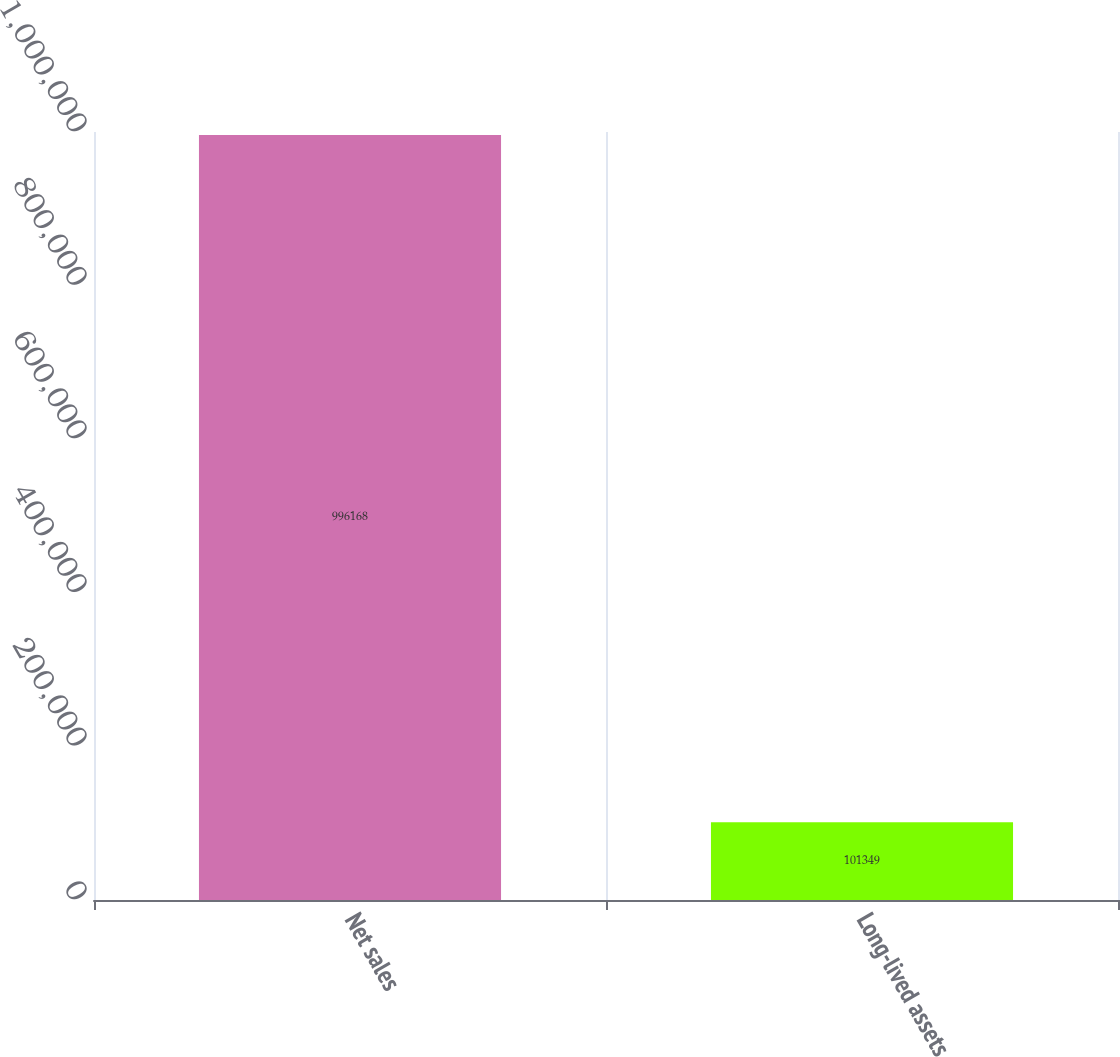Convert chart to OTSL. <chart><loc_0><loc_0><loc_500><loc_500><bar_chart><fcel>Net sales<fcel>Long-lived assets<nl><fcel>996168<fcel>101349<nl></chart> 